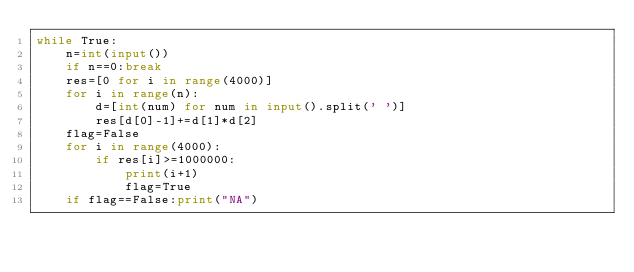<code> <loc_0><loc_0><loc_500><loc_500><_Python_>while True:
    n=int(input())
    if n==0:break
    res=[0 for i in range(4000)]
    for i in range(n):
        d=[int(num) for num in input().split(' ')]
        res[d[0]-1]+=d[1]*d[2]
    flag=False
    for i in range(4000):
        if res[i]>=1000000:
            print(i+1)
            flag=True
    if flag==False:print("NA")</code> 